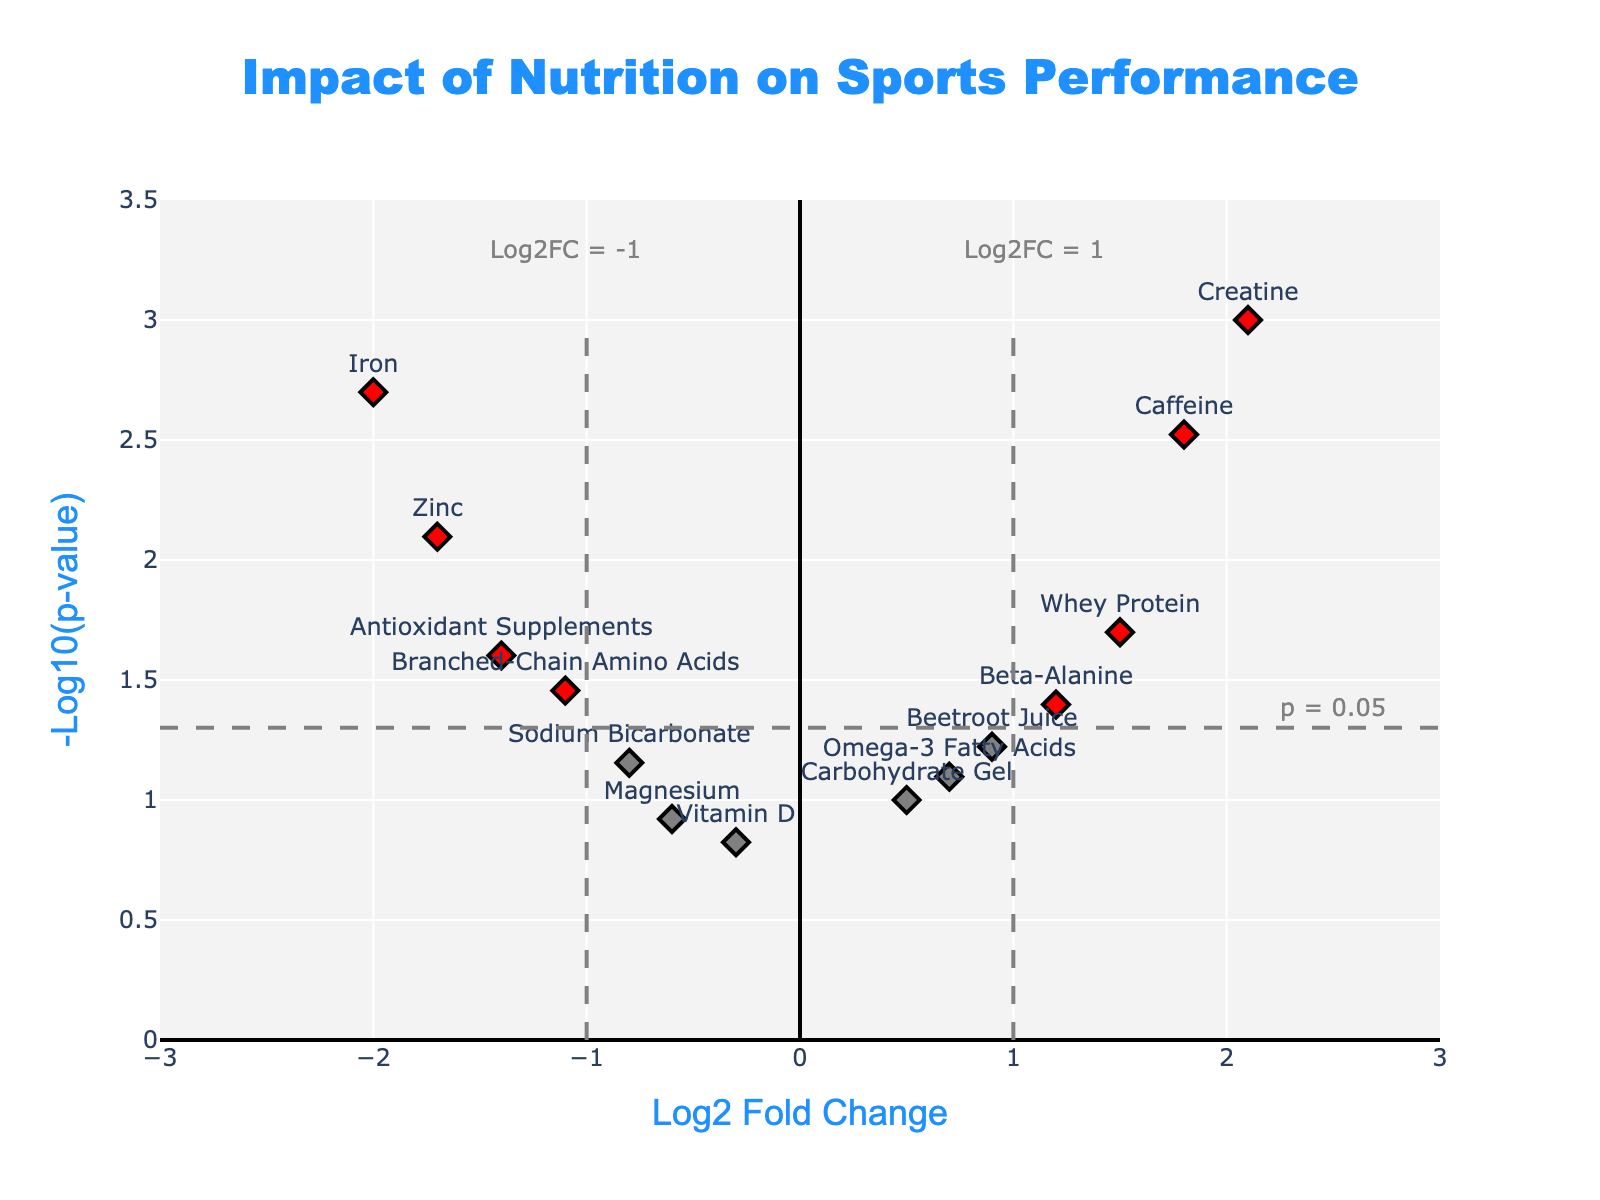What is the title of the figure? The title of the figure is located at the top center and reads "Impact of Nutrition on Sports Performance".
Answer: Impact of Nutrition on Sports Performance How many dietary interventions have a log2FoldChange greater than 1? Look at the x-axis values labeled "Log2 Fold Change" and count the number of points to the right of the vertical line at x=1.
Answer: 3 Which dietary intervention has the smallest p-value? Check the y-axis labeled "-Log10(p-value)" and find the point that is highest on the plot. Identify the corresponding gene.
Answer: Creatine What color represents interventions with both significant fold change and p-values? Notice the plot has different colored markers, and the description associating colors with significance is provided.
Answer: Red Are there any dietary interventions with negative log2FoldChange and p-value less than 0.05? If yes, name them. Check the left side of the plot for markers that are below the horizontal line at y=-log10(0.05). Identify the genes there.
Answer: Yes, Branched-Chain Amino Acids, Antioxidant Supplements, Zinc, Iron What's the log2FoldChange and p-value of Caffeine? Find the marker labeled "Caffeine" and refer to the hover text or point coordinates on the x and y-axis.
Answer: log2FoldChange: 1.8, p-value: 0.003 Which dietary intervention has the largest negative log2FoldChange? Look at the values on the left side of the x-axis and identify which marker is farthest to the left.
Answer: Iron Compare the significance of Beetroot Juice and Whey Protein based on their colors. Note the colors of Beetroot Juice and Whey Protein in the plot. Colors indicate statistical significance and fold change.
Answer: Beetroot Juice (grey), Whey Protein (blue) How many dietary interventions have a p-value of 0.05 or lower? Look for markers above the horizontal threshold line (-log10(0.05)) and count them.
Answer: 8 What does the vertical dashed line at x=1 represent? The annotation and the vertical line at x=1 indicate the log2 fold change threshold for significance.
Answer: Log2FC = 1 